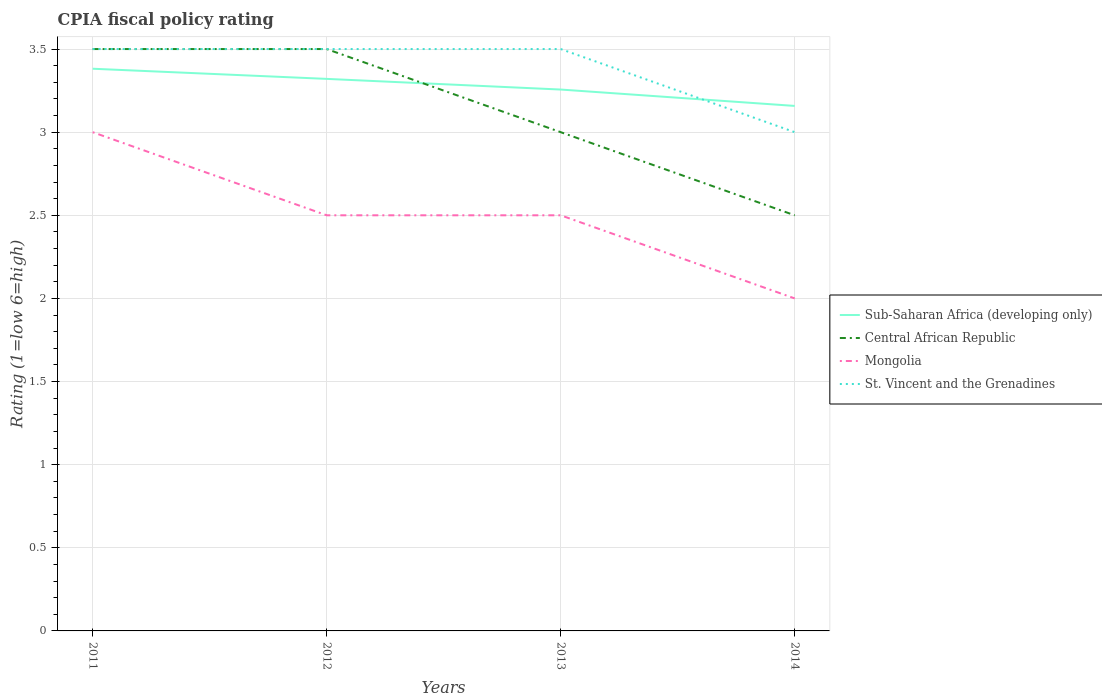Across all years, what is the maximum CPIA rating in St. Vincent and the Grenadines?
Give a very brief answer. 3. In which year was the CPIA rating in Central African Republic maximum?
Provide a short and direct response. 2014. What is the difference between the highest and the second highest CPIA rating in St. Vincent and the Grenadines?
Your answer should be very brief. 0.5. Is the CPIA rating in Sub-Saharan Africa (developing only) strictly greater than the CPIA rating in St. Vincent and the Grenadines over the years?
Offer a very short reply. No. What is the difference between two consecutive major ticks on the Y-axis?
Keep it short and to the point. 0.5. Are the values on the major ticks of Y-axis written in scientific E-notation?
Provide a succinct answer. No. Does the graph contain any zero values?
Provide a succinct answer. No. Does the graph contain grids?
Your answer should be very brief. Yes. How many legend labels are there?
Your response must be concise. 4. How are the legend labels stacked?
Your response must be concise. Vertical. What is the title of the graph?
Offer a terse response. CPIA fiscal policy rating. Does "Hungary" appear as one of the legend labels in the graph?
Your response must be concise. No. What is the label or title of the X-axis?
Give a very brief answer. Years. What is the label or title of the Y-axis?
Your answer should be very brief. Rating (1=low 6=high). What is the Rating (1=low 6=high) of Sub-Saharan Africa (developing only) in 2011?
Provide a succinct answer. 3.38. What is the Rating (1=low 6=high) of Mongolia in 2011?
Provide a short and direct response. 3. What is the Rating (1=low 6=high) in St. Vincent and the Grenadines in 2011?
Your answer should be very brief. 3.5. What is the Rating (1=low 6=high) of Sub-Saharan Africa (developing only) in 2012?
Offer a very short reply. 3.32. What is the Rating (1=low 6=high) of Central African Republic in 2012?
Ensure brevity in your answer.  3.5. What is the Rating (1=low 6=high) of Sub-Saharan Africa (developing only) in 2013?
Your answer should be very brief. 3.26. What is the Rating (1=low 6=high) of Sub-Saharan Africa (developing only) in 2014?
Offer a terse response. 3.16. What is the Rating (1=low 6=high) in St. Vincent and the Grenadines in 2014?
Offer a terse response. 3. Across all years, what is the maximum Rating (1=low 6=high) in Sub-Saharan Africa (developing only)?
Provide a succinct answer. 3.38. Across all years, what is the maximum Rating (1=low 6=high) of Mongolia?
Ensure brevity in your answer.  3. Across all years, what is the maximum Rating (1=low 6=high) of St. Vincent and the Grenadines?
Ensure brevity in your answer.  3.5. Across all years, what is the minimum Rating (1=low 6=high) in Sub-Saharan Africa (developing only)?
Your response must be concise. 3.16. Across all years, what is the minimum Rating (1=low 6=high) of Central African Republic?
Provide a short and direct response. 2.5. Across all years, what is the minimum Rating (1=low 6=high) in Mongolia?
Offer a terse response. 2. Across all years, what is the minimum Rating (1=low 6=high) in St. Vincent and the Grenadines?
Offer a very short reply. 3. What is the total Rating (1=low 6=high) of Sub-Saharan Africa (developing only) in the graph?
Offer a very short reply. 13.12. What is the total Rating (1=low 6=high) of Central African Republic in the graph?
Your response must be concise. 12.5. What is the total Rating (1=low 6=high) in St. Vincent and the Grenadines in the graph?
Your response must be concise. 13.5. What is the difference between the Rating (1=low 6=high) in Sub-Saharan Africa (developing only) in 2011 and that in 2012?
Provide a short and direct response. 0.06. What is the difference between the Rating (1=low 6=high) of Central African Republic in 2011 and that in 2012?
Your response must be concise. 0. What is the difference between the Rating (1=low 6=high) of Sub-Saharan Africa (developing only) in 2011 and that in 2013?
Offer a terse response. 0.13. What is the difference between the Rating (1=low 6=high) in Sub-Saharan Africa (developing only) in 2011 and that in 2014?
Offer a terse response. 0.22. What is the difference between the Rating (1=low 6=high) of Central African Republic in 2011 and that in 2014?
Your answer should be compact. 1. What is the difference between the Rating (1=low 6=high) in Mongolia in 2011 and that in 2014?
Provide a succinct answer. 1. What is the difference between the Rating (1=low 6=high) of St. Vincent and the Grenadines in 2011 and that in 2014?
Give a very brief answer. 0.5. What is the difference between the Rating (1=low 6=high) in Sub-Saharan Africa (developing only) in 2012 and that in 2013?
Your answer should be very brief. 0.06. What is the difference between the Rating (1=low 6=high) of Central African Republic in 2012 and that in 2013?
Provide a short and direct response. 0.5. What is the difference between the Rating (1=low 6=high) in Mongolia in 2012 and that in 2013?
Your response must be concise. 0. What is the difference between the Rating (1=low 6=high) in Sub-Saharan Africa (developing only) in 2012 and that in 2014?
Make the answer very short. 0.16. What is the difference between the Rating (1=low 6=high) of St. Vincent and the Grenadines in 2012 and that in 2014?
Make the answer very short. 0.5. What is the difference between the Rating (1=low 6=high) in Sub-Saharan Africa (developing only) in 2013 and that in 2014?
Your answer should be very brief. 0.1. What is the difference between the Rating (1=low 6=high) in Central African Republic in 2013 and that in 2014?
Your response must be concise. 0.5. What is the difference between the Rating (1=low 6=high) of Sub-Saharan Africa (developing only) in 2011 and the Rating (1=low 6=high) of Central African Republic in 2012?
Ensure brevity in your answer.  -0.12. What is the difference between the Rating (1=low 6=high) in Sub-Saharan Africa (developing only) in 2011 and the Rating (1=low 6=high) in Mongolia in 2012?
Your response must be concise. 0.88. What is the difference between the Rating (1=low 6=high) of Sub-Saharan Africa (developing only) in 2011 and the Rating (1=low 6=high) of St. Vincent and the Grenadines in 2012?
Offer a terse response. -0.12. What is the difference between the Rating (1=low 6=high) of Central African Republic in 2011 and the Rating (1=low 6=high) of Mongolia in 2012?
Ensure brevity in your answer.  1. What is the difference between the Rating (1=low 6=high) in Central African Republic in 2011 and the Rating (1=low 6=high) in St. Vincent and the Grenadines in 2012?
Provide a short and direct response. 0. What is the difference between the Rating (1=low 6=high) of Mongolia in 2011 and the Rating (1=low 6=high) of St. Vincent and the Grenadines in 2012?
Provide a short and direct response. -0.5. What is the difference between the Rating (1=low 6=high) in Sub-Saharan Africa (developing only) in 2011 and the Rating (1=low 6=high) in Central African Republic in 2013?
Ensure brevity in your answer.  0.38. What is the difference between the Rating (1=low 6=high) of Sub-Saharan Africa (developing only) in 2011 and the Rating (1=low 6=high) of Mongolia in 2013?
Give a very brief answer. 0.88. What is the difference between the Rating (1=low 6=high) of Sub-Saharan Africa (developing only) in 2011 and the Rating (1=low 6=high) of St. Vincent and the Grenadines in 2013?
Keep it short and to the point. -0.12. What is the difference between the Rating (1=low 6=high) of Central African Republic in 2011 and the Rating (1=low 6=high) of Mongolia in 2013?
Provide a succinct answer. 1. What is the difference between the Rating (1=low 6=high) in Sub-Saharan Africa (developing only) in 2011 and the Rating (1=low 6=high) in Central African Republic in 2014?
Offer a very short reply. 0.88. What is the difference between the Rating (1=low 6=high) of Sub-Saharan Africa (developing only) in 2011 and the Rating (1=low 6=high) of Mongolia in 2014?
Keep it short and to the point. 1.38. What is the difference between the Rating (1=low 6=high) in Sub-Saharan Africa (developing only) in 2011 and the Rating (1=low 6=high) in St. Vincent and the Grenadines in 2014?
Ensure brevity in your answer.  0.38. What is the difference between the Rating (1=low 6=high) of Mongolia in 2011 and the Rating (1=low 6=high) of St. Vincent and the Grenadines in 2014?
Provide a succinct answer. 0. What is the difference between the Rating (1=low 6=high) in Sub-Saharan Africa (developing only) in 2012 and the Rating (1=low 6=high) in Central African Republic in 2013?
Ensure brevity in your answer.  0.32. What is the difference between the Rating (1=low 6=high) in Sub-Saharan Africa (developing only) in 2012 and the Rating (1=low 6=high) in Mongolia in 2013?
Your answer should be very brief. 0.82. What is the difference between the Rating (1=low 6=high) of Sub-Saharan Africa (developing only) in 2012 and the Rating (1=low 6=high) of St. Vincent and the Grenadines in 2013?
Offer a very short reply. -0.18. What is the difference between the Rating (1=low 6=high) of Sub-Saharan Africa (developing only) in 2012 and the Rating (1=low 6=high) of Central African Republic in 2014?
Your response must be concise. 0.82. What is the difference between the Rating (1=low 6=high) in Sub-Saharan Africa (developing only) in 2012 and the Rating (1=low 6=high) in Mongolia in 2014?
Your answer should be compact. 1.32. What is the difference between the Rating (1=low 6=high) in Sub-Saharan Africa (developing only) in 2012 and the Rating (1=low 6=high) in St. Vincent and the Grenadines in 2014?
Keep it short and to the point. 0.32. What is the difference between the Rating (1=low 6=high) of Central African Republic in 2012 and the Rating (1=low 6=high) of Mongolia in 2014?
Make the answer very short. 1.5. What is the difference between the Rating (1=low 6=high) of Sub-Saharan Africa (developing only) in 2013 and the Rating (1=low 6=high) of Central African Republic in 2014?
Make the answer very short. 0.76. What is the difference between the Rating (1=low 6=high) in Sub-Saharan Africa (developing only) in 2013 and the Rating (1=low 6=high) in Mongolia in 2014?
Offer a very short reply. 1.26. What is the difference between the Rating (1=low 6=high) of Sub-Saharan Africa (developing only) in 2013 and the Rating (1=low 6=high) of St. Vincent and the Grenadines in 2014?
Provide a succinct answer. 0.26. What is the average Rating (1=low 6=high) in Sub-Saharan Africa (developing only) per year?
Your response must be concise. 3.28. What is the average Rating (1=low 6=high) in Central African Republic per year?
Provide a succinct answer. 3.12. What is the average Rating (1=low 6=high) in Mongolia per year?
Make the answer very short. 2.5. What is the average Rating (1=low 6=high) of St. Vincent and the Grenadines per year?
Your response must be concise. 3.38. In the year 2011, what is the difference between the Rating (1=low 6=high) of Sub-Saharan Africa (developing only) and Rating (1=low 6=high) of Central African Republic?
Make the answer very short. -0.12. In the year 2011, what is the difference between the Rating (1=low 6=high) of Sub-Saharan Africa (developing only) and Rating (1=low 6=high) of Mongolia?
Keep it short and to the point. 0.38. In the year 2011, what is the difference between the Rating (1=low 6=high) of Sub-Saharan Africa (developing only) and Rating (1=low 6=high) of St. Vincent and the Grenadines?
Your answer should be very brief. -0.12. In the year 2011, what is the difference between the Rating (1=low 6=high) in Central African Republic and Rating (1=low 6=high) in St. Vincent and the Grenadines?
Offer a terse response. 0. In the year 2011, what is the difference between the Rating (1=low 6=high) in Mongolia and Rating (1=low 6=high) in St. Vincent and the Grenadines?
Offer a terse response. -0.5. In the year 2012, what is the difference between the Rating (1=low 6=high) of Sub-Saharan Africa (developing only) and Rating (1=low 6=high) of Central African Republic?
Your response must be concise. -0.18. In the year 2012, what is the difference between the Rating (1=low 6=high) of Sub-Saharan Africa (developing only) and Rating (1=low 6=high) of Mongolia?
Your answer should be compact. 0.82. In the year 2012, what is the difference between the Rating (1=low 6=high) of Sub-Saharan Africa (developing only) and Rating (1=low 6=high) of St. Vincent and the Grenadines?
Provide a succinct answer. -0.18. In the year 2012, what is the difference between the Rating (1=low 6=high) in Central African Republic and Rating (1=low 6=high) in Mongolia?
Provide a short and direct response. 1. In the year 2012, what is the difference between the Rating (1=low 6=high) in Central African Republic and Rating (1=low 6=high) in St. Vincent and the Grenadines?
Make the answer very short. 0. In the year 2012, what is the difference between the Rating (1=low 6=high) of Mongolia and Rating (1=low 6=high) of St. Vincent and the Grenadines?
Give a very brief answer. -1. In the year 2013, what is the difference between the Rating (1=low 6=high) in Sub-Saharan Africa (developing only) and Rating (1=low 6=high) in Central African Republic?
Keep it short and to the point. 0.26. In the year 2013, what is the difference between the Rating (1=low 6=high) in Sub-Saharan Africa (developing only) and Rating (1=low 6=high) in Mongolia?
Offer a terse response. 0.76. In the year 2013, what is the difference between the Rating (1=low 6=high) in Sub-Saharan Africa (developing only) and Rating (1=low 6=high) in St. Vincent and the Grenadines?
Provide a short and direct response. -0.24. In the year 2013, what is the difference between the Rating (1=low 6=high) of Central African Republic and Rating (1=low 6=high) of Mongolia?
Provide a succinct answer. 0.5. In the year 2013, what is the difference between the Rating (1=low 6=high) in Central African Republic and Rating (1=low 6=high) in St. Vincent and the Grenadines?
Ensure brevity in your answer.  -0.5. In the year 2013, what is the difference between the Rating (1=low 6=high) in Mongolia and Rating (1=low 6=high) in St. Vincent and the Grenadines?
Give a very brief answer. -1. In the year 2014, what is the difference between the Rating (1=low 6=high) in Sub-Saharan Africa (developing only) and Rating (1=low 6=high) in Central African Republic?
Offer a terse response. 0.66. In the year 2014, what is the difference between the Rating (1=low 6=high) in Sub-Saharan Africa (developing only) and Rating (1=low 6=high) in Mongolia?
Your answer should be very brief. 1.16. In the year 2014, what is the difference between the Rating (1=low 6=high) in Sub-Saharan Africa (developing only) and Rating (1=low 6=high) in St. Vincent and the Grenadines?
Provide a short and direct response. 0.16. In the year 2014, what is the difference between the Rating (1=low 6=high) of Mongolia and Rating (1=low 6=high) of St. Vincent and the Grenadines?
Offer a very short reply. -1. What is the ratio of the Rating (1=low 6=high) of Sub-Saharan Africa (developing only) in 2011 to that in 2012?
Offer a terse response. 1.02. What is the ratio of the Rating (1=low 6=high) in Mongolia in 2011 to that in 2012?
Offer a terse response. 1.2. What is the ratio of the Rating (1=low 6=high) of Sub-Saharan Africa (developing only) in 2011 to that in 2013?
Provide a succinct answer. 1.04. What is the ratio of the Rating (1=low 6=high) in Mongolia in 2011 to that in 2013?
Your response must be concise. 1.2. What is the ratio of the Rating (1=low 6=high) in Sub-Saharan Africa (developing only) in 2011 to that in 2014?
Your answer should be compact. 1.07. What is the ratio of the Rating (1=low 6=high) in Mongolia in 2011 to that in 2014?
Provide a short and direct response. 1.5. What is the ratio of the Rating (1=low 6=high) in Sub-Saharan Africa (developing only) in 2012 to that in 2013?
Your answer should be compact. 1.02. What is the ratio of the Rating (1=low 6=high) of Central African Republic in 2012 to that in 2013?
Offer a very short reply. 1.17. What is the ratio of the Rating (1=low 6=high) of Mongolia in 2012 to that in 2013?
Offer a very short reply. 1. What is the ratio of the Rating (1=low 6=high) in Sub-Saharan Africa (developing only) in 2012 to that in 2014?
Make the answer very short. 1.05. What is the ratio of the Rating (1=low 6=high) of St. Vincent and the Grenadines in 2012 to that in 2014?
Ensure brevity in your answer.  1.17. What is the ratio of the Rating (1=low 6=high) in Sub-Saharan Africa (developing only) in 2013 to that in 2014?
Offer a very short reply. 1.03. What is the ratio of the Rating (1=low 6=high) in Central African Republic in 2013 to that in 2014?
Give a very brief answer. 1.2. What is the difference between the highest and the second highest Rating (1=low 6=high) in Sub-Saharan Africa (developing only)?
Your response must be concise. 0.06. What is the difference between the highest and the second highest Rating (1=low 6=high) of Central African Republic?
Your answer should be compact. 0. What is the difference between the highest and the second highest Rating (1=low 6=high) of St. Vincent and the Grenadines?
Provide a short and direct response. 0. What is the difference between the highest and the lowest Rating (1=low 6=high) of Sub-Saharan Africa (developing only)?
Make the answer very short. 0.22. 